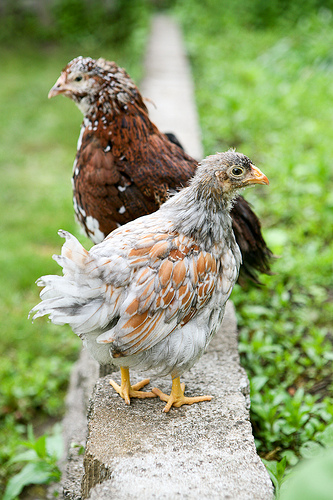<image>
Is the chicken above the grass? Yes. The chicken is positioned above the grass in the vertical space, higher up in the scene. 